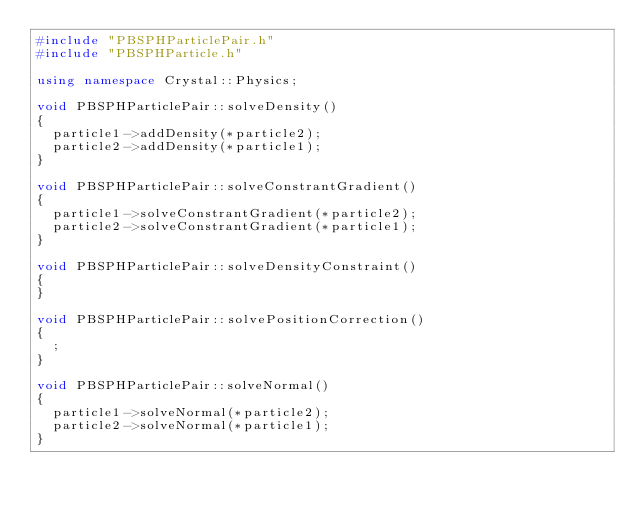<code> <loc_0><loc_0><loc_500><loc_500><_C++_>#include "PBSPHParticlePair.h"
#include "PBSPHParticle.h"

using namespace Crystal::Physics;

void PBSPHParticlePair::solveDensity()
{
	particle1->addDensity(*particle2);
	particle2->addDensity(*particle1);
}

void PBSPHParticlePair::solveConstrantGradient()
{
	particle1->solveConstrantGradient(*particle2);
	particle2->solveConstrantGradient(*particle1);
}

void PBSPHParticlePair::solveDensityConstraint()
{
}

void PBSPHParticlePair::solvePositionCorrection()
{
	;
}

void PBSPHParticlePair::solveNormal()
{
	particle1->solveNormal(*particle2);
	particle2->solveNormal(*particle1);
}
</code> 